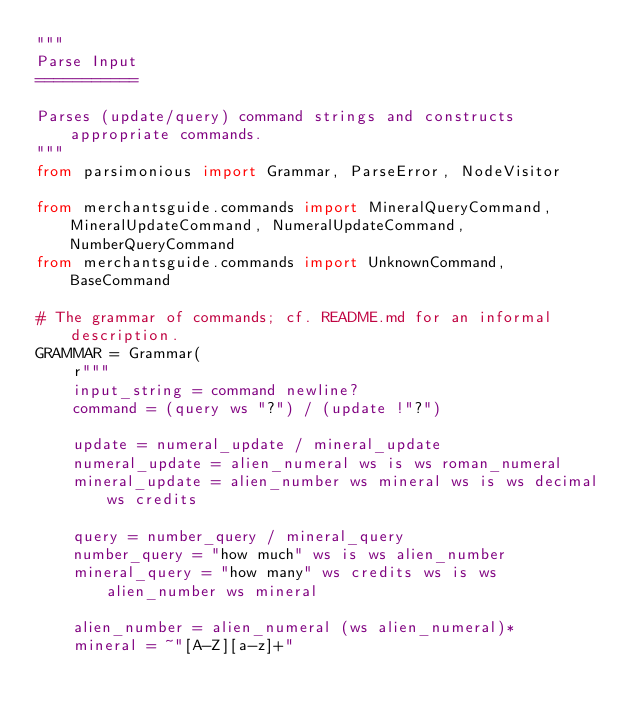<code> <loc_0><loc_0><loc_500><loc_500><_Python_>"""
Parse Input
===========

Parses (update/query) command strings and constructs appropriate commands.
"""
from parsimonious import Grammar, ParseError, NodeVisitor

from merchantsguide.commands import MineralQueryCommand, MineralUpdateCommand, NumeralUpdateCommand, NumberQueryCommand
from merchantsguide.commands import UnknownCommand, BaseCommand

# The grammar of commands; cf. README.md for an informal description.
GRAMMAR = Grammar(
    r"""
    input_string = command newline?
    command = (query ws "?") / (update !"?")
    
    update = numeral_update / mineral_update
    numeral_update = alien_numeral ws is ws roman_numeral
    mineral_update = alien_number ws mineral ws is ws decimal ws credits
    
    query = number_query / mineral_query
    number_query = "how much" ws is ws alien_number
    mineral_query = "how many" ws credits ws is ws alien_number ws mineral
    
    alien_number = alien_numeral (ws alien_numeral)*
    mineral = ~"[A-Z][a-z]+"
    </code> 